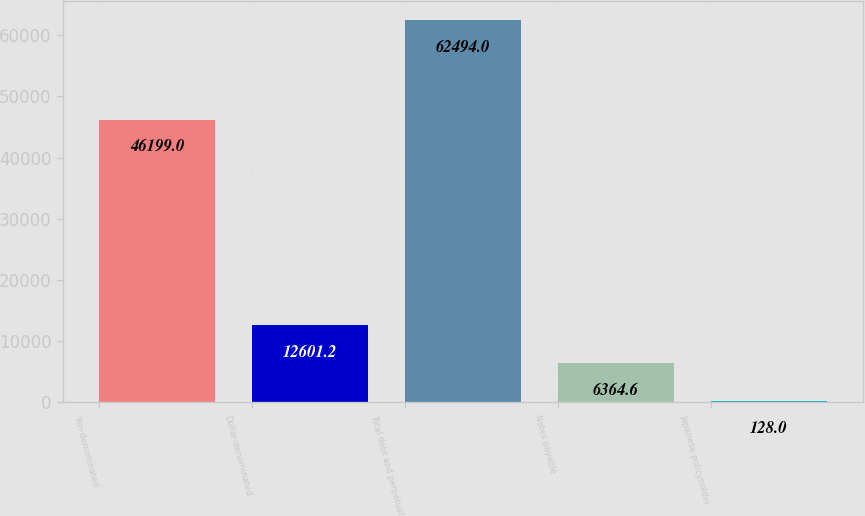Convert chart to OTSL. <chart><loc_0><loc_0><loc_500><loc_500><bar_chart><fcel>Yen-denominated<fcel>Dollar-denominated<fcel>Total debt and perpetual<fcel>Notes payable<fcel>Japanese policyholder<nl><fcel>46199<fcel>12601.2<fcel>62494<fcel>6364.6<fcel>128<nl></chart> 